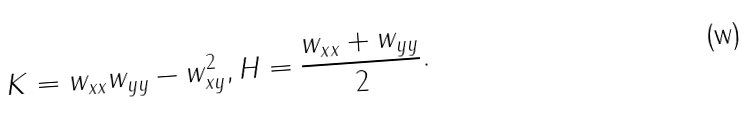Convert formula to latex. <formula><loc_0><loc_0><loc_500><loc_500>K = w _ { x x } w _ { y y } - w _ { x y } ^ { 2 } , H = \frac { w _ { x x } + w _ { y y } } { 2 } .</formula> 